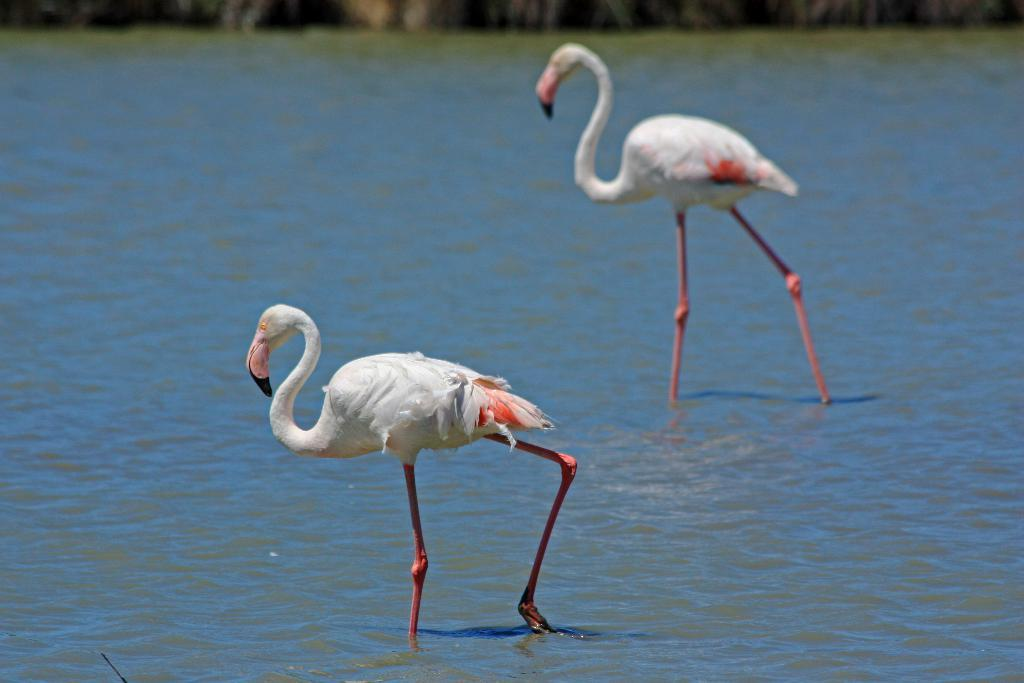What type of animals are in the image? There are two flamingo birds in the image. Where are the flamingo birds located? The flamingo birds are in water. What type of string is being used by the army in the image? There is no army or string present in the image; it features two flamingo birds in water. 